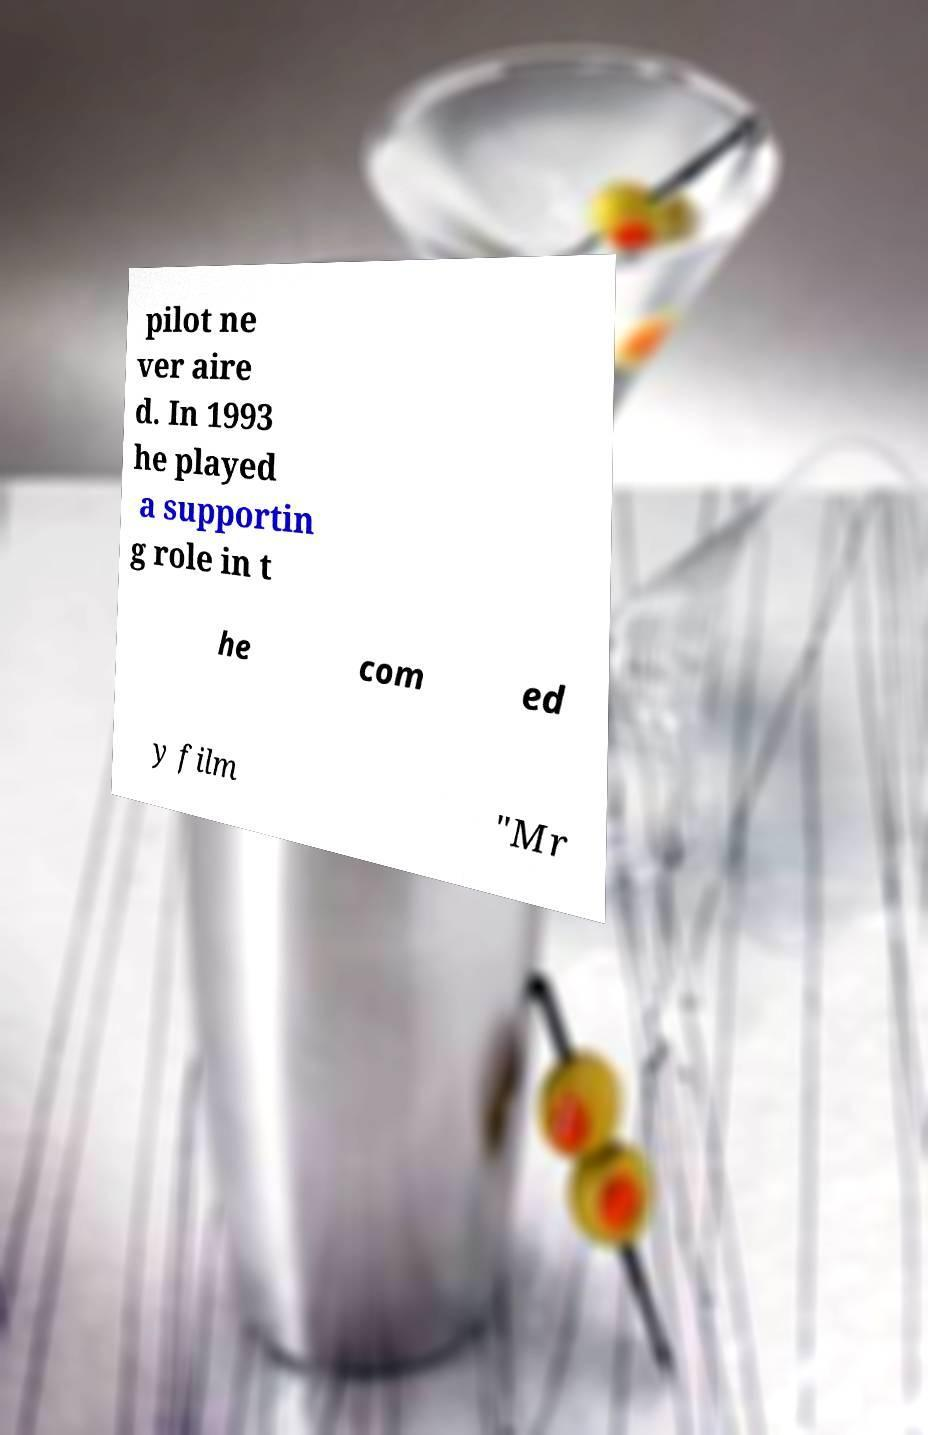Could you extract and type out the text from this image? pilot ne ver aire d. In 1993 he played a supportin g role in t he com ed y film "Mr 